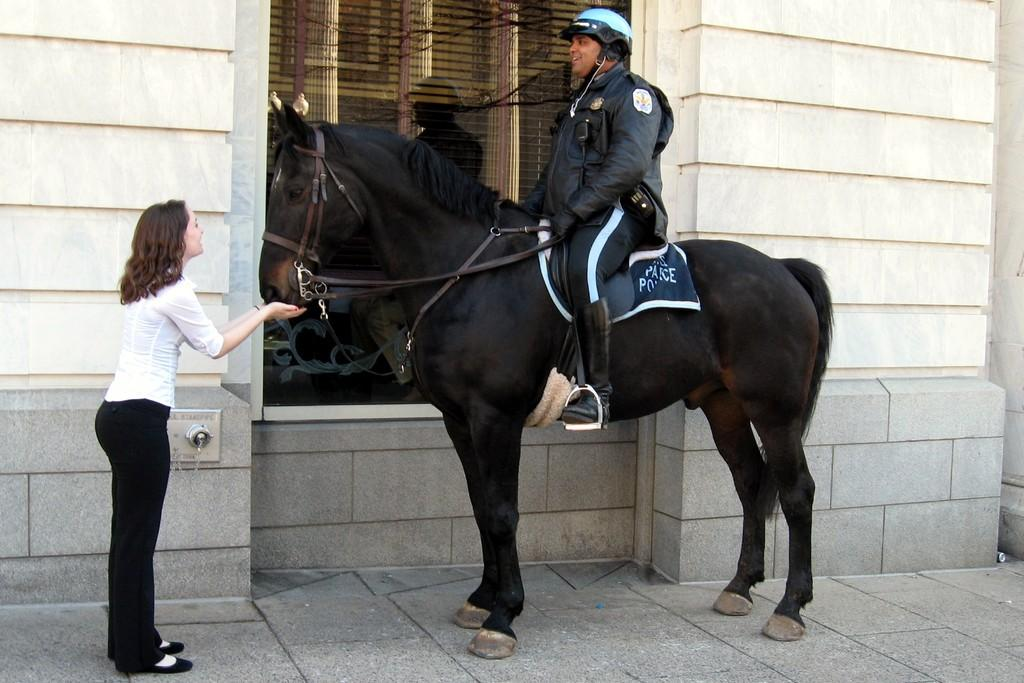What is the man doing in the image? The man is sitting on a black horse in the image. Where is the man located in the image? The man is on the left side of the image. What is the woman doing in the image? The woman is standing in the image and holding a horse. What type of hook is the man using to ride the horse in the image? There is no hook present in the image; the man is simply sitting on the horse. Can you tell me which vein the woman is holding in the image? There is no vein present in the image; the woman is holding a horse. 